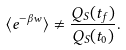<formula> <loc_0><loc_0><loc_500><loc_500>\langle e ^ { - \beta w } \rangle \neq \frac { Q _ { S } ( t _ { f } ) } { Q _ { S } ( t _ { 0 } ) } .</formula> 